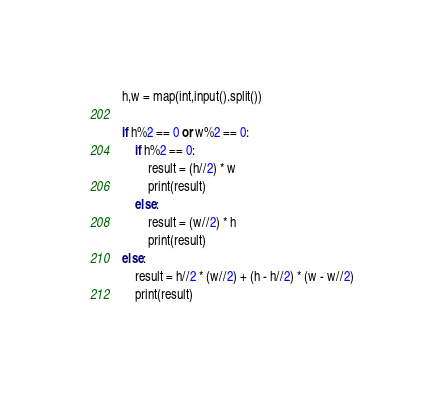Convert code to text. <code><loc_0><loc_0><loc_500><loc_500><_Python_>h,w = map(int,input().split())

if h%2 == 0 or w%2 == 0:
    if h%2 == 0:
        result = (h//2) * w
        print(result)
    else:
        result = (w//2) * h
        print(result)
else:
    result = h//2 * (w//2) + (h - h//2) * (w - w//2)
    print(result)</code> 